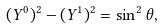<formula> <loc_0><loc_0><loc_500><loc_500>( Y ^ { 0 } ) ^ { 2 } - ( Y ^ { 1 } ) ^ { 2 } = \sin ^ { 2 } \theta ,</formula> 